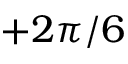<formula> <loc_0><loc_0><loc_500><loc_500>+ 2 \pi / 6</formula> 